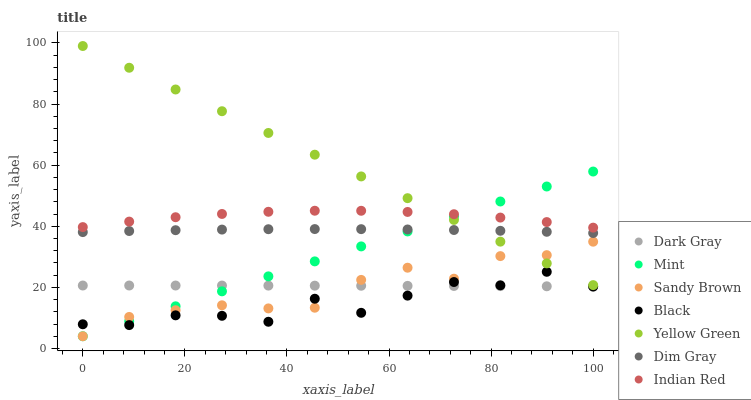Does Black have the minimum area under the curve?
Answer yes or no. Yes. Does Yellow Green have the maximum area under the curve?
Answer yes or no. Yes. Does Mint have the minimum area under the curve?
Answer yes or no. No. Does Mint have the maximum area under the curve?
Answer yes or no. No. Is Mint the smoothest?
Answer yes or no. Yes. Is Black the roughest?
Answer yes or no. Yes. Is Yellow Green the smoothest?
Answer yes or no. No. Is Yellow Green the roughest?
Answer yes or no. No. Does Mint have the lowest value?
Answer yes or no. Yes. Does Yellow Green have the lowest value?
Answer yes or no. No. Does Yellow Green have the highest value?
Answer yes or no. Yes. Does Mint have the highest value?
Answer yes or no. No. Is Sandy Brown less than Indian Red?
Answer yes or no. Yes. Is Indian Red greater than Sandy Brown?
Answer yes or no. Yes. Does Black intersect Mint?
Answer yes or no. Yes. Is Black less than Mint?
Answer yes or no. No. Is Black greater than Mint?
Answer yes or no. No. Does Sandy Brown intersect Indian Red?
Answer yes or no. No. 